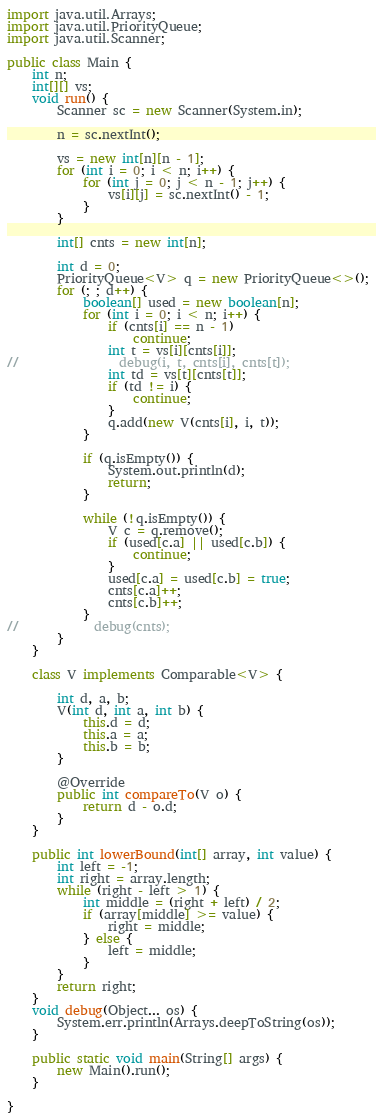Convert code to text. <code><loc_0><loc_0><loc_500><loc_500><_Java_>
import java.util.Arrays;
import java.util.PriorityQueue;
import java.util.Scanner;

public class Main {
    int n;
    int[][] vs;
    void run() {
        Scanner sc = new Scanner(System.in);

        n = sc.nextInt();

        vs = new int[n][n - 1];
        for (int i = 0; i < n; i++) {
            for (int j = 0; j < n - 1; j++) {
                vs[i][j] = sc.nextInt() - 1;
            }
        }

        int[] cnts = new int[n];

        int d = 0;
        PriorityQueue<V> q = new PriorityQueue<>();
        for (; ; d++) {
            boolean[] used = new boolean[n];
            for (int i = 0; i < n; i++) {
                if (cnts[i] == n - 1)
                    continue;
                int t = vs[i][cnts[i]];
//                debug(i, t, cnts[i], cnts[t]);
                int td = vs[t][cnts[t]];
                if (td != i) {
                    continue;
                }
                q.add(new V(cnts[i], i, t));
            }

            if (q.isEmpty()) {
                System.out.println(d);
                return;
            }

            while (!q.isEmpty()) {
                V c = q.remove();
                if (used[c.a] || used[c.b]) {
                    continue;
                }
                used[c.a] = used[c.b] = true;
                cnts[c.a]++;
                cnts[c.b]++;
            }
//            debug(cnts);
        }
    }

    class V implements Comparable<V> {

        int d, a, b;
        V(int d, int a, int b) {
            this.d = d;
            this.a = a;
            this.b = b;
        }

        @Override
        public int compareTo(V o) {
            return d - o.d;
        }
    }

    public int lowerBound(int[] array, int value) {
        int left = -1;
        int right = array.length;
        while (right - left > 1) {
            int middle = (right + left) / 2;
            if (array[middle] >= value) {
                right = middle;
            } else {
                left = middle;
            }
        }
        return right;
    }
    void debug(Object... os) {
        System.err.println(Arrays.deepToString(os));
    }

    public static void main(String[] args) {
        new Main().run();
    }

}
</code> 